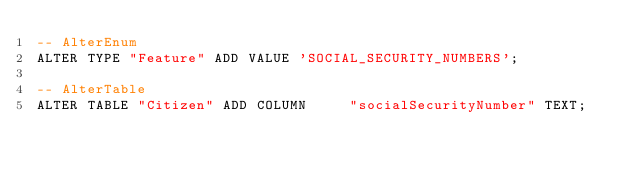Convert code to text. <code><loc_0><loc_0><loc_500><loc_500><_SQL_>-- AlterEnum
ALTER TYPE "Feature" ADD VALUE 'SOCIAL_SECURITY_NUMBERS';

-- AlterTable
ALTER TABLE "Citizen" ADD COLUMN     "socialSecurityNumber" TEXT;
</code> 